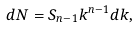Convert formula to latex. <formula><loc_0><loc_0><loc_500><loc_500>d N = S _ { n - 1 } k ^ { n - 1 } d k ,</formula> 